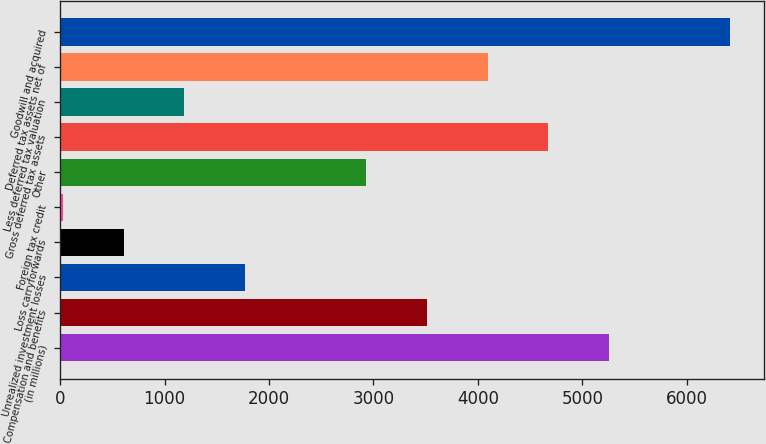<chart> <loc_0><loc_0><loc_500><loc_500><bar_chart><fcel>(in millions)<fcel>Compensation and benefits<fcel>Unrealized investment losses<fcel>Loss carryforwards<fcel>Foreign tax credit<fcel>Other<fcel>Gross deferred tax assets<fcel>Less deferred tax valuation<fcel>Deferred tax assets net of<fcel>Goodwill and acquired<nl><fcel>5256.1<fcel>3513.4<fcel>1770.7<fcel>608.9<fcel>28<fcel>2932.5<fcel>4675.2<fcel>1189.8<fcel>4094.3<fcel>6417.9<nl></chart> 